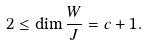Convert formula to latex. <formula><loc_0><loc_0><loc_500><loc_500>2 \leq \dim \frac { W } { J } = c + 1 .</formula> 